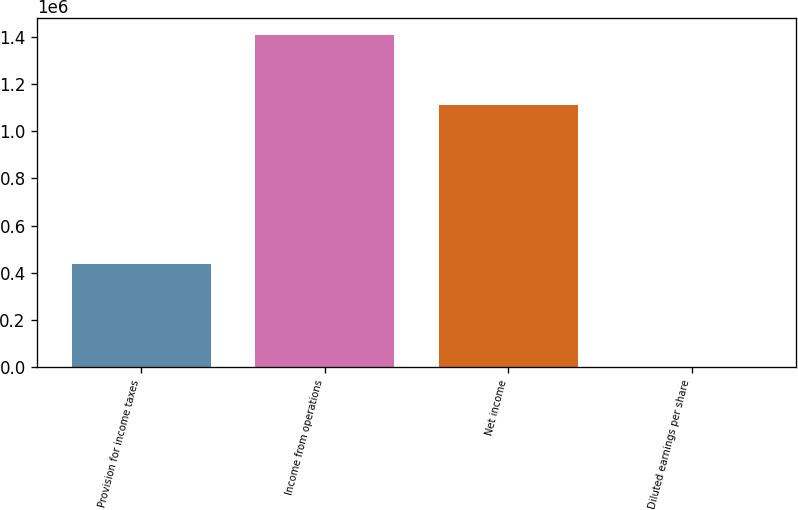<chart> <loc_0><loc_0><loc_500><loc_500><bar_chart><fcel>Provision for income taxes<fcel>Income from operations<fcel>Net income<fcel>Diluted earnings per share<nl><fcel>436889<fcel>1.40748e+06<fcel>1.11017e+06<fcel>0.78<nl></chart> 